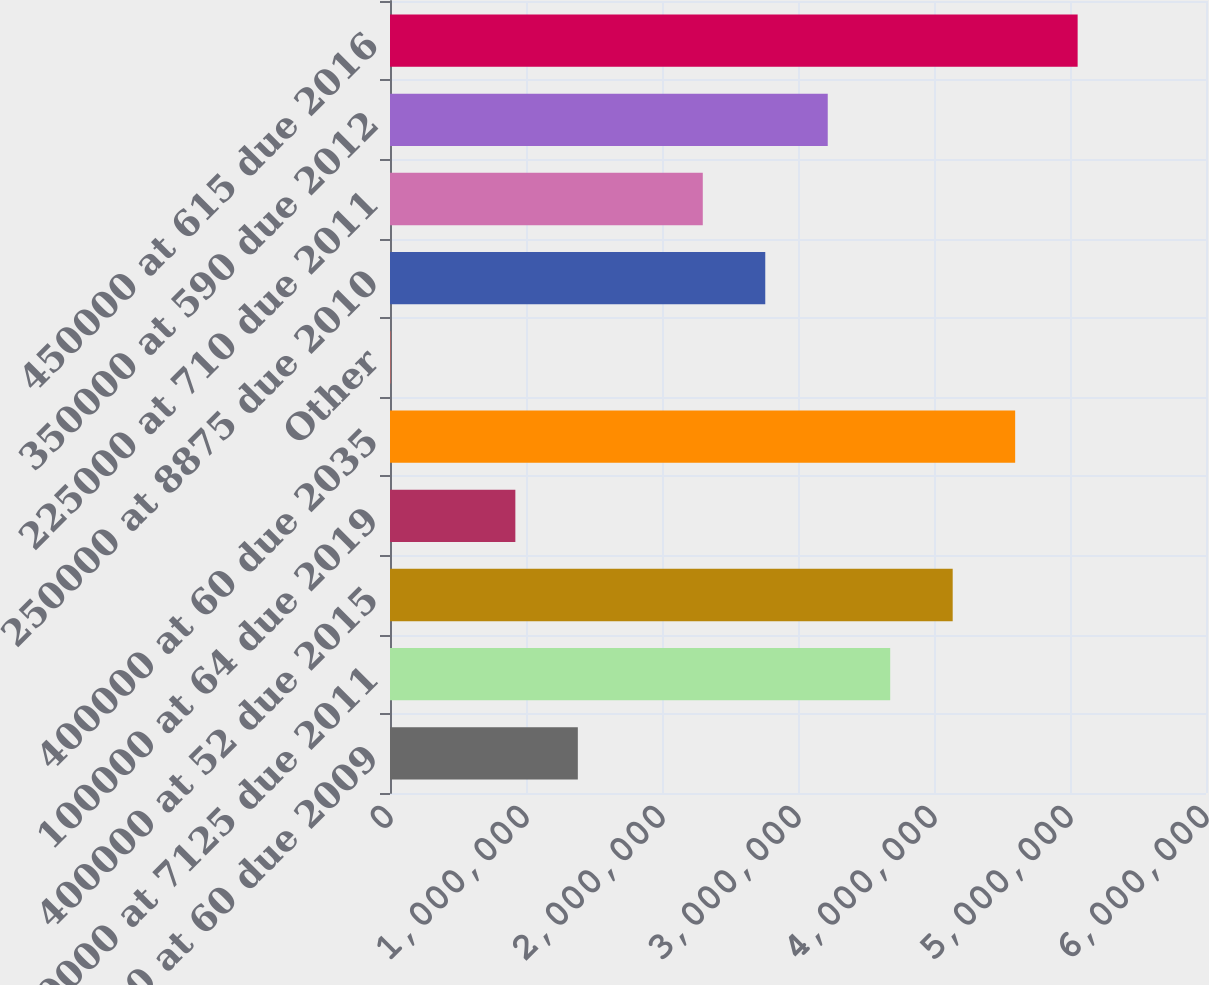Convert chart. <chart><loc_0><loc_0><loc_500><loc_500><bar_chart><fcel>100000 at 60 due 2009<fcel>400000 at 7125 due 2011<fcel>400000 at 52 due 2015<fcel>100000 at 64 due 2019<fcel>400000 at 60 due 2035<fcel>Other<fcel>250000 at 8875 due 2010<fcel>225000 at 710 due 2011<fcel>350000 at 590 due 2012<fcel>450000 at 615 due 2016<nl><fcel>1.38111e+06<fcel>3.67803e+06<fcel>4.13742e+06<fcel>921727<fcel>4.5968e+06<fcel>2958<fcel>2.75927e+06<fcel>2.29988e+06<fcel>3.21865e+06<fcel>5.05619e+06<nl></chart> 